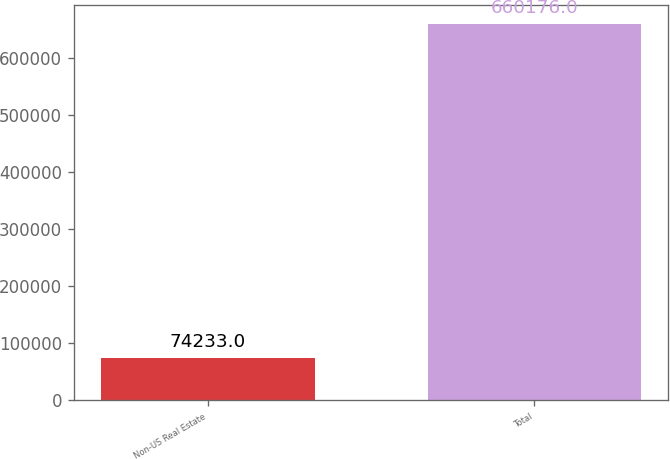Convert chart to OTSL. <chart><loc_0><loc_0><loc_500><loc_500><bar_chart><fcel>Non-US Real Estate<fcel>Total<nl><fcel>74233<fcel>660176<nl></chart> 